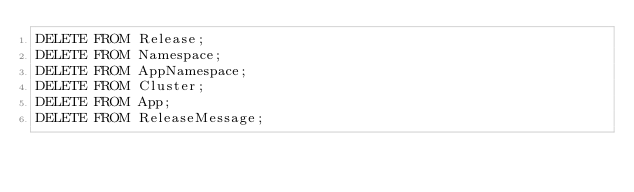<code> <loc_0><loc_0><loc_500><loc_500><_SQL_>DELETE FROM Release;
DELETE FROM Namespace;
DELETE FROM AppNamespace;
DELETE FROM Cluster;
DELETE FROM App;
DELETE FROM ReleaseMessage;

</code> 